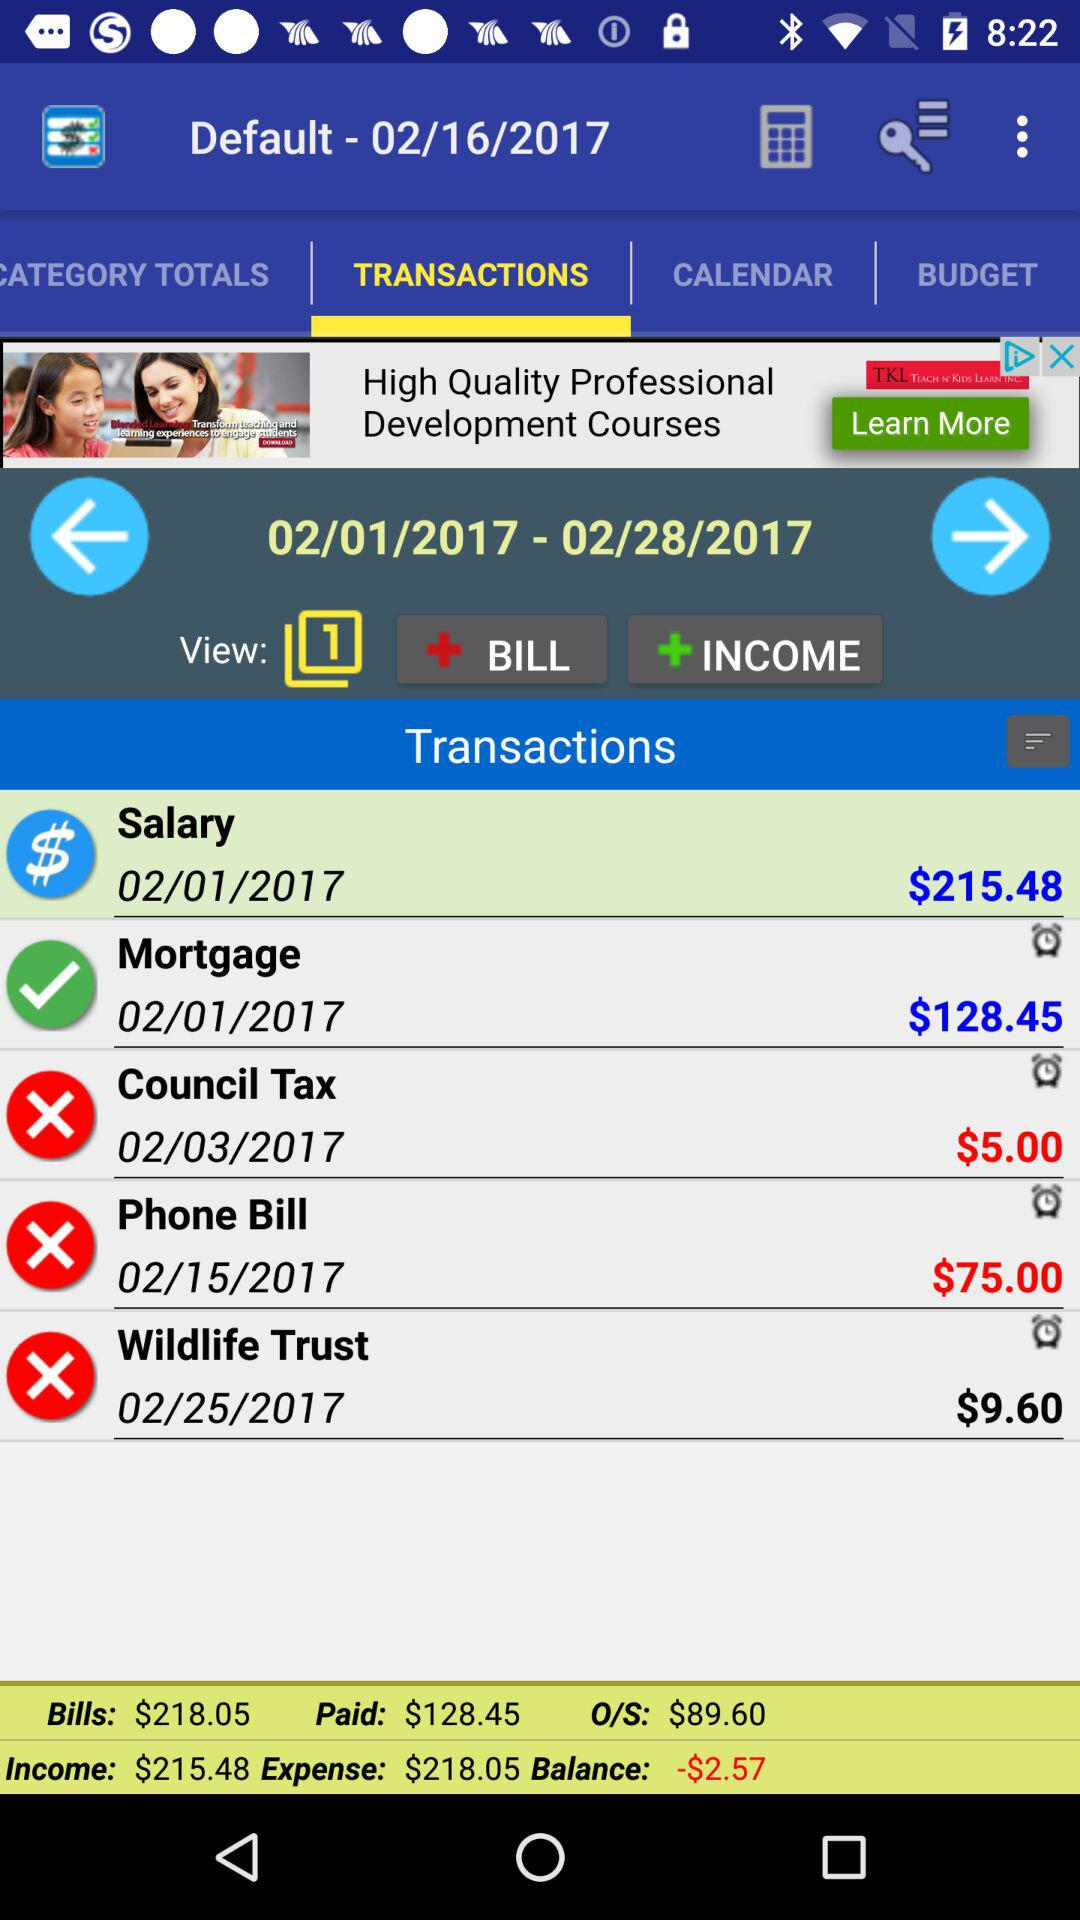What is the currency of amount? The currency of amount is dollars. 